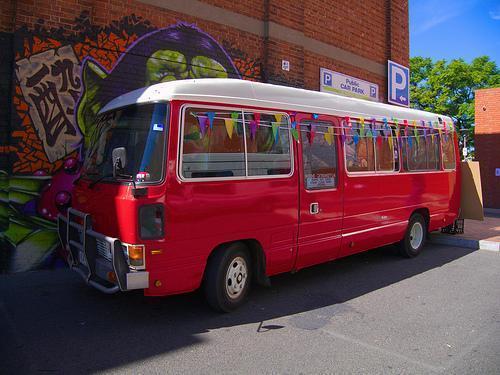How many white trucks are there?
Give a very brief answer. 0. 